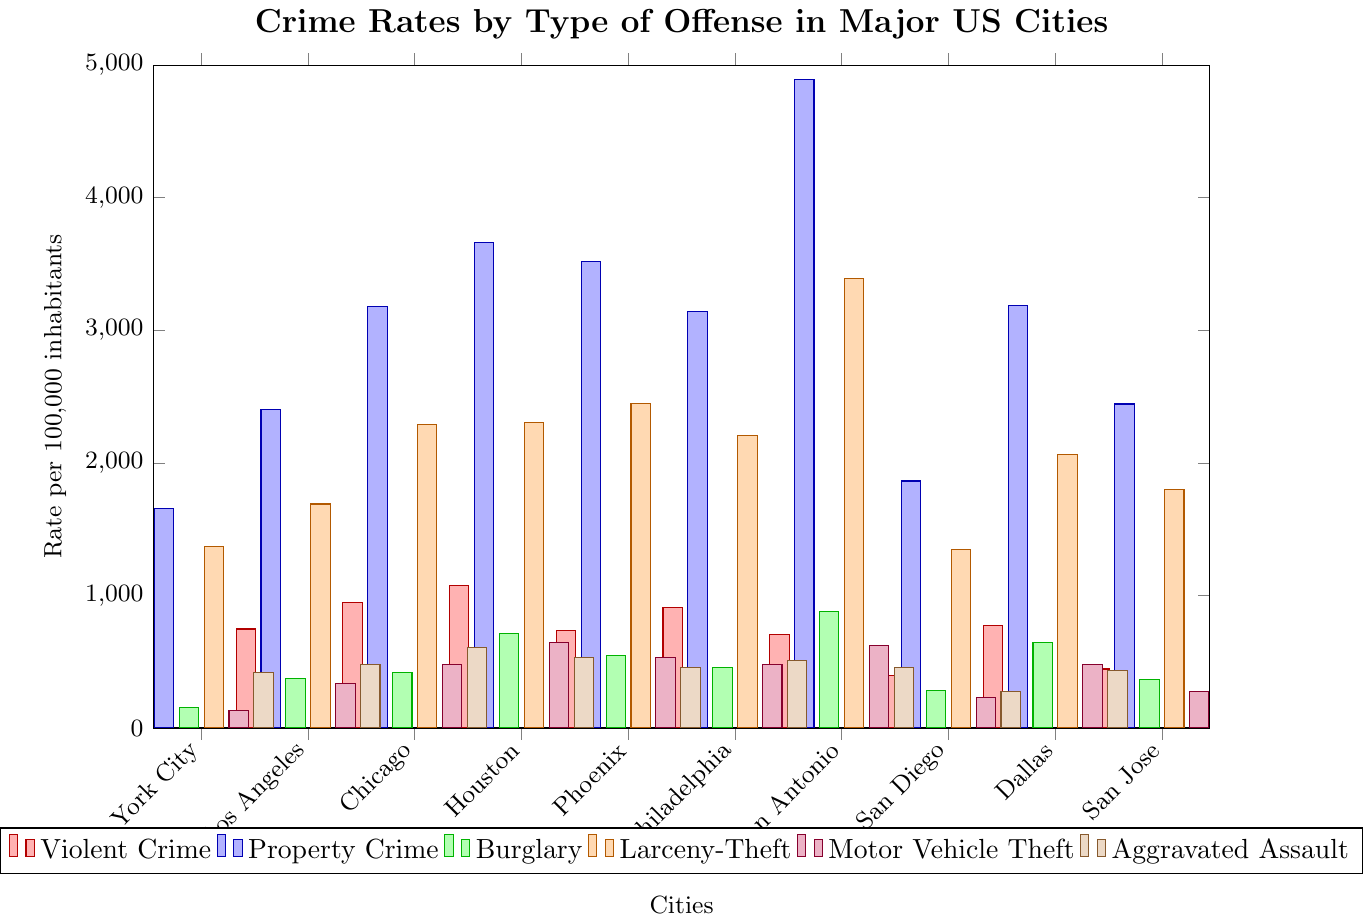Which city has the highest rate of violent crime? Violence crime rates are visualized in red. By comparing the height of the red bars for all cities, Houston is the highest.
Answer: Houston Which city has the lowest rate of aggravated assault? Aggravated assault rates are shown in brown. The shortest brown bar appears for San Diego.
Answer: San Diego What is the total property crime rate for Chicago and Phoenix combined? Property crime rates are represented by blue bars. For Chicago, it is 3181.8, and for Phoenix, it is 3520.4. Summing them gives 3181.8 + 3520.4 = 6702.2.
Answer: 6702.2 Which city has a higher rate of larceny-theft, New York City or San Antonio? Larceny-theft rates are in orange. By comparing the heights of these bars for New York City (1368.3) and San Antonio (3393.2), San Antonio clearly has a higher rate.
Answer: San Antonio How does the motor vehicle theft rate in Los Angeles compare to Dallas? Motor vehicle theft rates are shown in purple. Los Angeles has a rate of 334.0, whereas Dallas has 479.9. Comparing these, Dallas has a higher rate.
Answer: Dallas Which offense type has the lowest crime rate in San Jose? Examining the various colored bars for San Jose, the shortest bar represents motor vehicle theft with a rate of 275.6.
Answer: Motor Vehicle Theft What is the average rate of property crime across all the cities? Summing all property crime rates: 1654.5 + 2399.5 + 3181.8 + 3660.0 + 3520.4 + 3143.3 + 4891.1 + 1863.1 + 3183.5 + 2443.7 = 29941.9. There are 10 cities, so the average is 29941.9 / 10 = 2994.19.
Answer: 2994.19 Which city has the highest combined rate for burglary and motor vehicle theft? Look for the city where the sum of green (burglary) and purple (motor vehicle theft) bars is the greatest. For San Antonio, it is 877.9 + 620.0 = 1497.9, which is the highest among the cities.
Answer: San Antonio How does the violent crime rate in Philadelphia compare to New York City? Violent crime rates are in red. Philadelphia has a rate of 909.4, and New York City has 585.8. Thus, Philadelphia has a higher rate.
Answer: Philadelphia In which city is the difference between property crime rate and violent crime rate the largest? Calculate property crime minus violent crime for each city:
  - New York City: 1654.5 - 585.8 = 1068.7
  - Los Angeles: 2399.5 - 746.5 = 1653.0
  - Chicago: 3181.8 - 943.2 = 2238.6
  - Houston: 3660.0 - 1072.9 = 2587.1
  - Phoenix: 3520.4 - 733.1 = 2787.3
  - Philadelphia: 3143.3 - 909.4 = 2233.9
  - San Antonio: 4891.1 - 707.5 = 4183.6
  - San Diego: 1863.1 - 393.8 = 1469.3
  - Dallas: 3183.5 - 775.4 = 2408.1
  - San Jose: 2443.7 - 445.3 = 1998.4
  - San Antonio has the largest difference, which is 4183.6.
Answer: San Antonio 